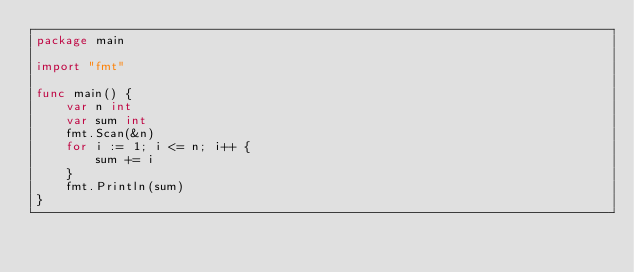Convert code to text. <code><loc_0><loc_0><loc_500><loc_500><_Go_>package main

import "fmt"

func main() {
	var n int
	var sum int
	fmt.Scan(&n)
	for i := 1; i <= n; i++ {
		sum += i
	}
	fmt.Println(sum)
}
</code> 